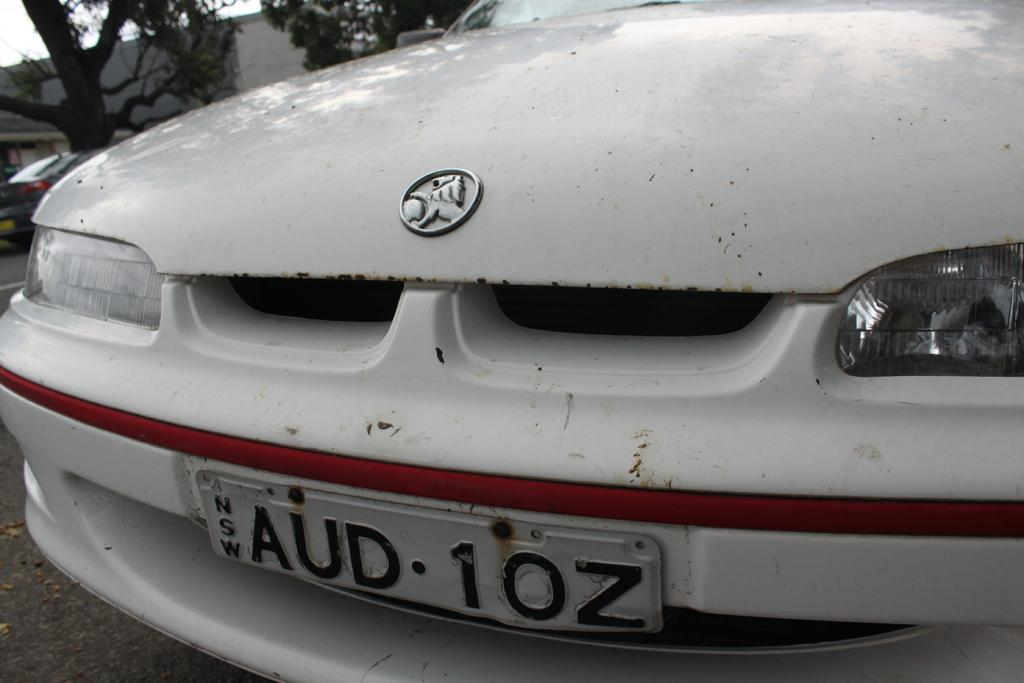What color is the car in the image? The car in the image is white. Where is the car located? The car is on the road. Can you describe the background of the image? There is another car, a tree, a building, and the sky visible in the background. What type of reaction can be seen from the crow in the image? There is no crow present in the image, so it is not possible to observe any reaction. 